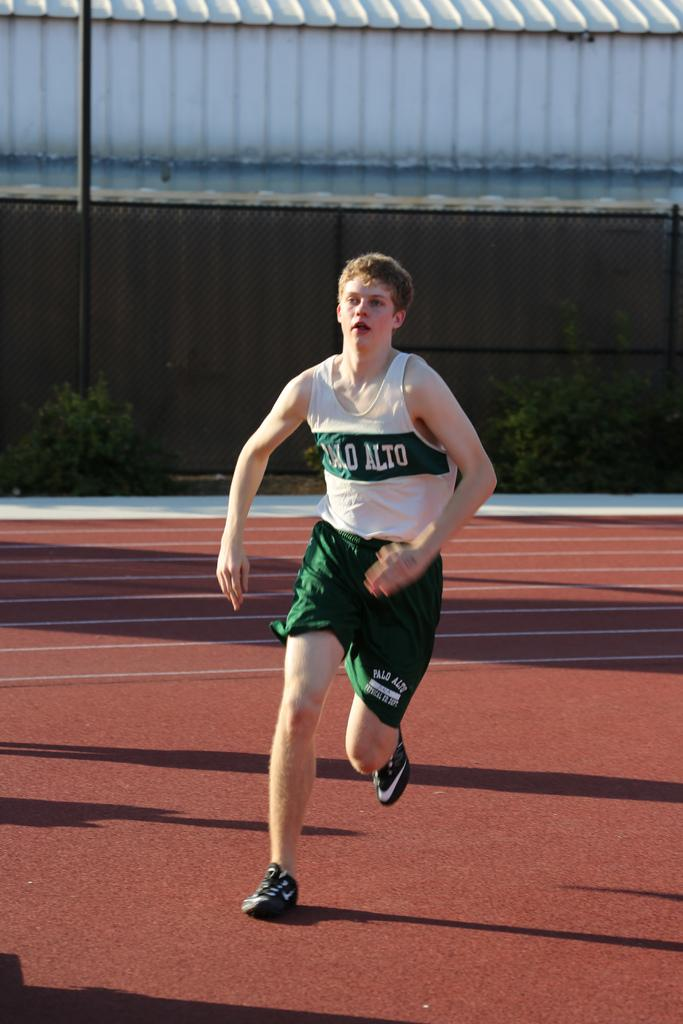<image>
Relay a brief, clear account of the picture shown. A young man runs on a track wearing a Palo Alto vest. 